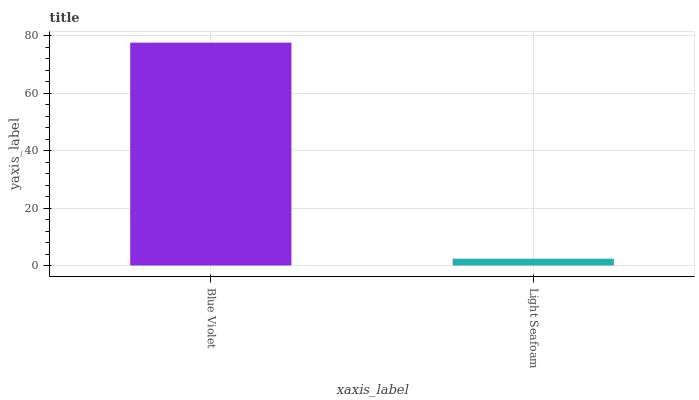Is Light Seafoam the minimum?
Answer yes or no. Yes. Is Blue Violet the maximum?
Answer yes or no. Yes. Is Light Seafoam the maximum?
Answer yes or no. No. Is Blue Violet greater than Light Seafoam?
Answer yes or no. Yes. Is Light Seafoam less than Blue Violet?
Answer yes or no. Yes. Is Light Seafoam greater than Blue Violet?
Answer yes or no. No. Is Blue Violet less than Light Seafoam?
Answer yes or no. No. Is Blue Violet the high median?
Answer yes or no. Yes. Is Light Seafoam the low median?
Answer yes or no. Yes. Is Light Seafoam the high median?
Answer yes or no. No. Is Blue Violet the low median?
Answer yes or no. No. 